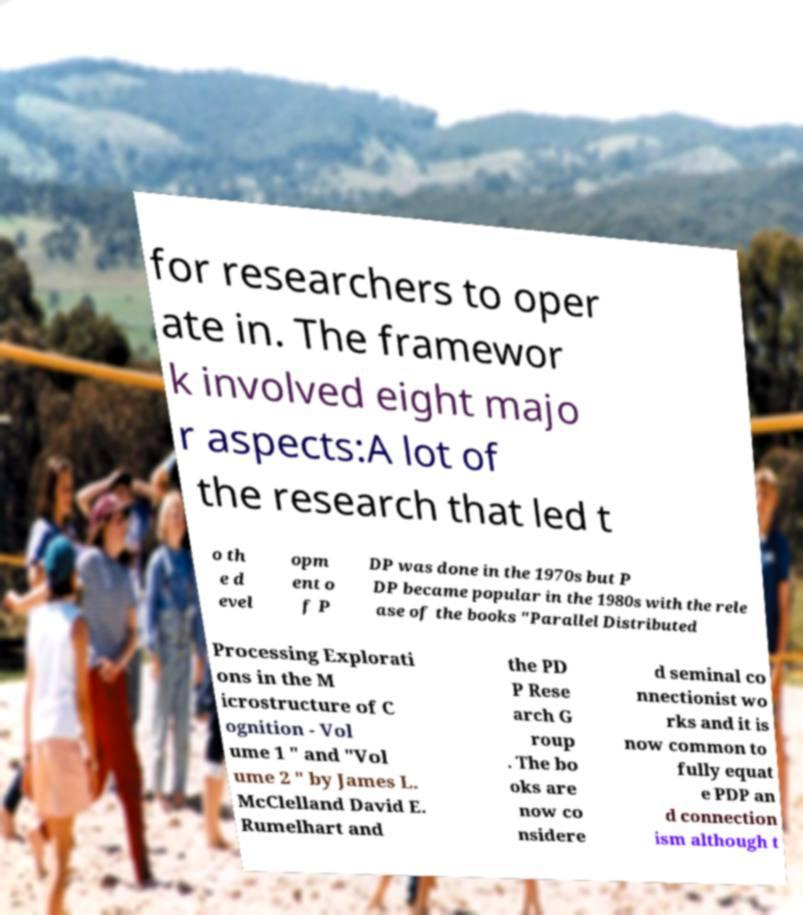Could you extract and type out the text from this image? for researchers to oper ate in. The framewor k involved eight majo r aspects:A lot of the research that led t o th e d evel opm ent o f P DP was done in the 1970s but P DP became popular in the 1980s with the rele ase of the books "Parallel Distributed Processing Explorati ons in the M icrostructure of C ognition - Vol ume 1 " and "Vol ume 2 " by James L. McClelland David E. Rumelhart and the PD P Rese arch G roup . The bo oks are now co nsidere d seminal co nnectionist wo rks and it is now common to fully equat e PDP an d connection ism although t 